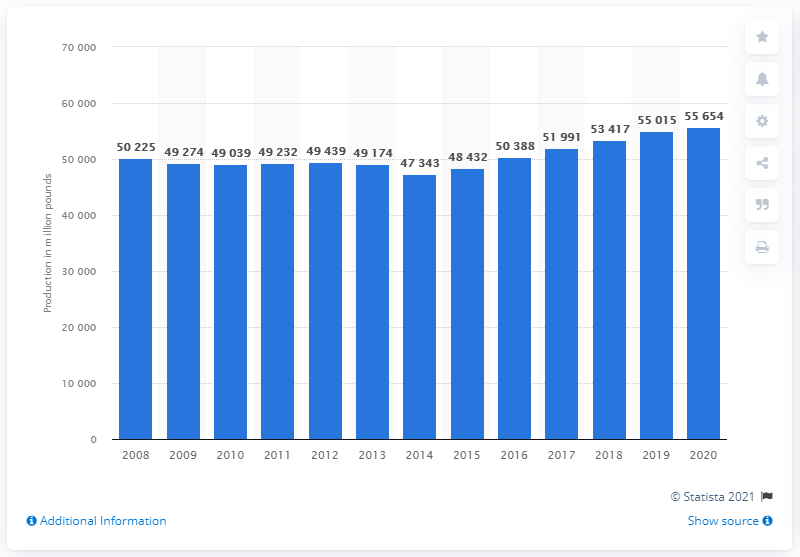Draw attention to some important aspects in this diagram. The total commercial red meat production of the United States in 2020 was 556,544 heads. 